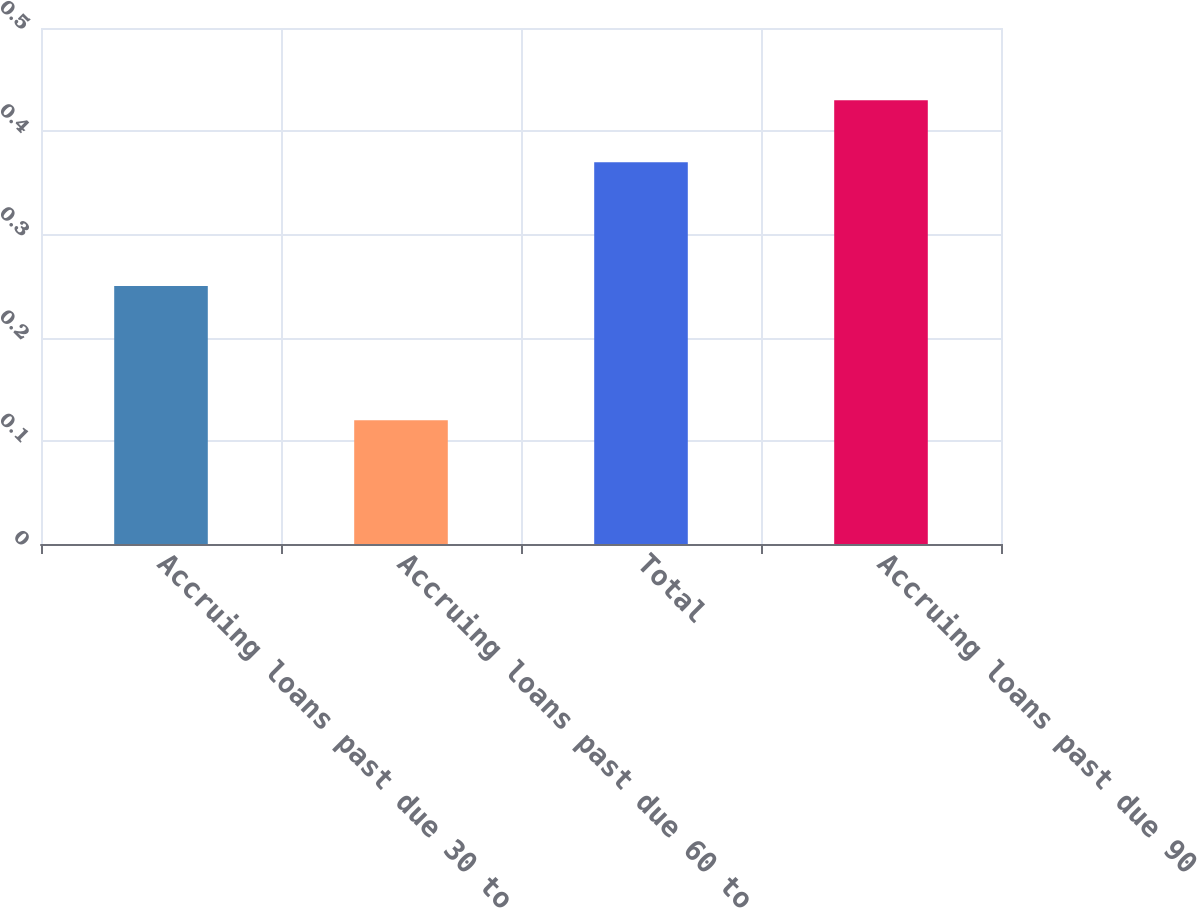Convert chart. <chart><loc_0><loc_0><loc_500><loc_500><bar_chart><fcel>Accruing loans past due 30 to<fcel>Accruing loans past due 60 to<fcel>Total<fcel>Accruing loans past due 90<nl><fcel>0.25<fcel>0.12<fcel>0.37<fcel>0.43<nl></chart> 